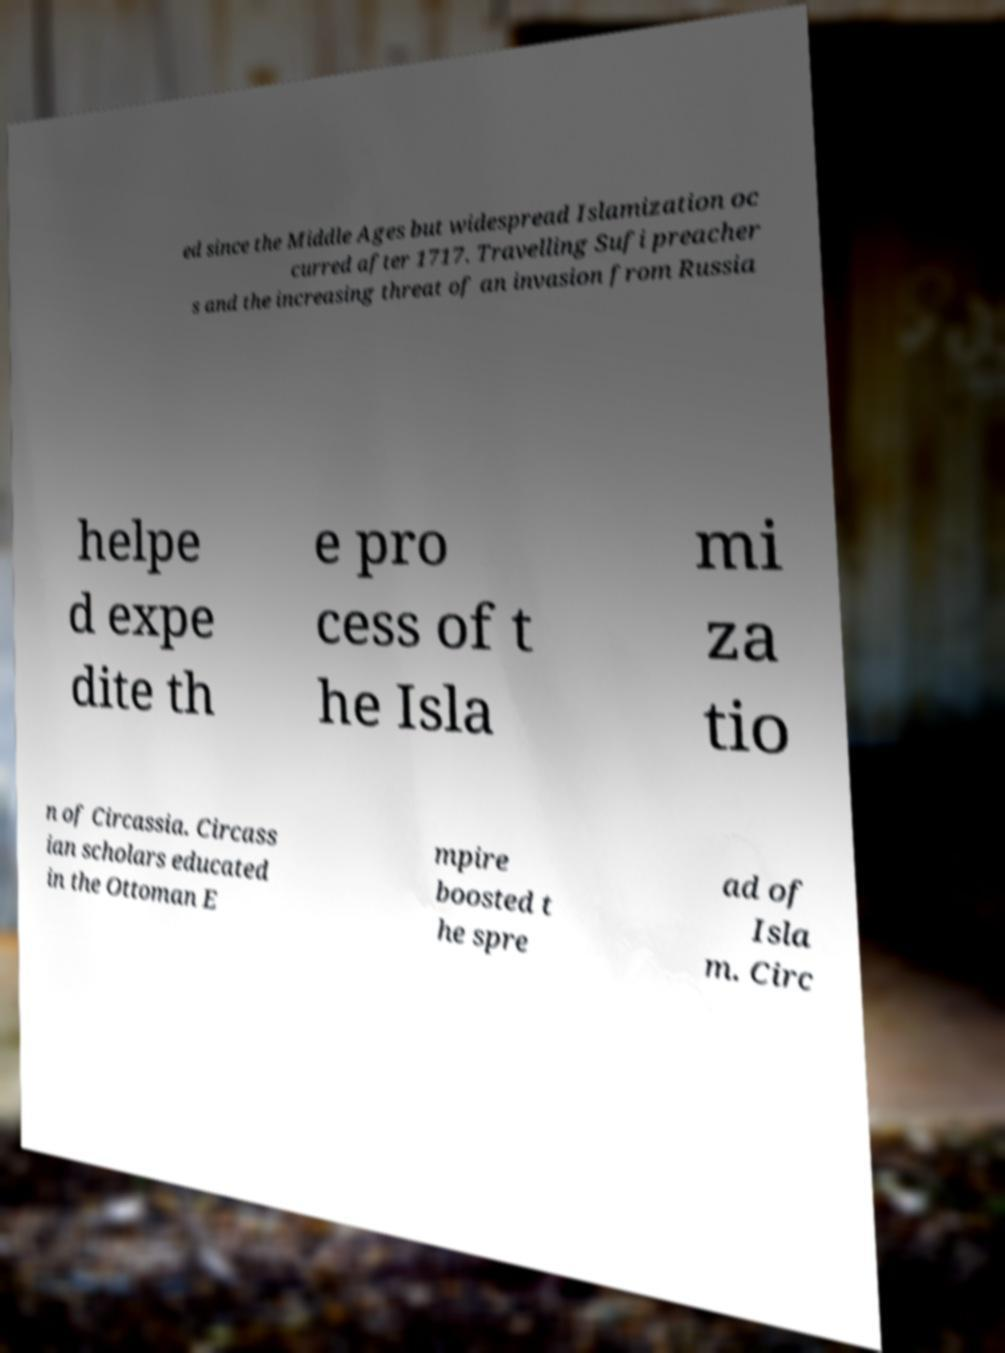Please read and relay the text visible in this image. What does it say? ed since the Middle Ages but widespread Islamization oc curred after 1717. Travelling Sufi preacher s and the increasing threat of an invasion from Russia helpe d expe dite th e pro cess of t he Isla mi za tio n of Circassia. Circass ian scholars educated in the Ottoman E mpire boosted t he spre ad of Isla m. Circ 